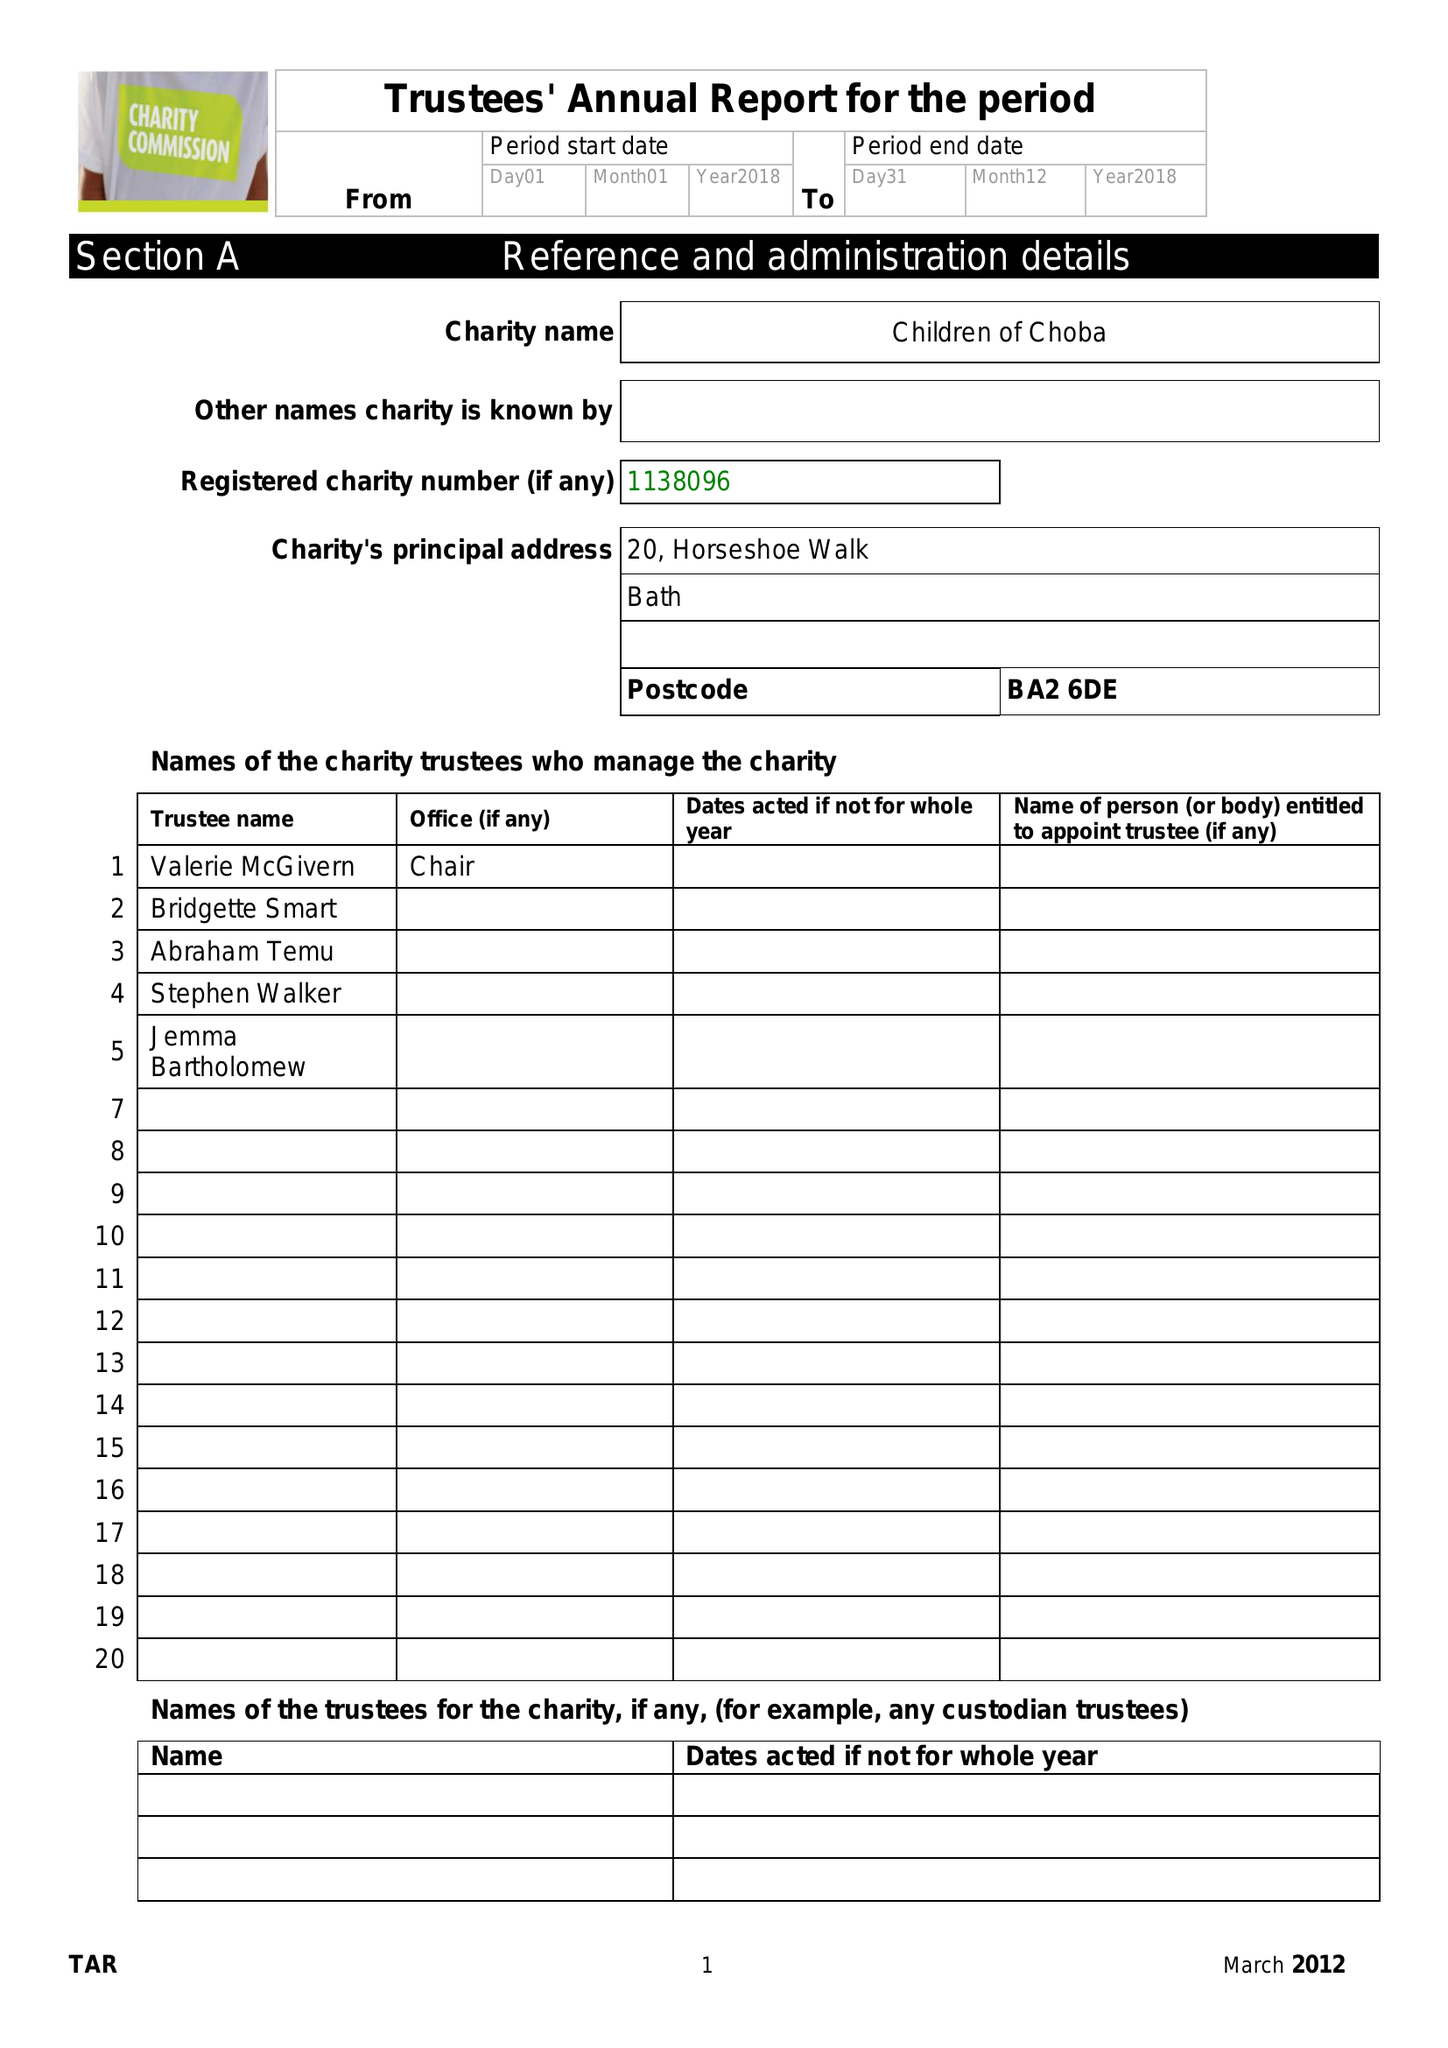What is the value for the address__street_line?
Answer the question using a single word or phrase. 20 HORSESHOE WALK 